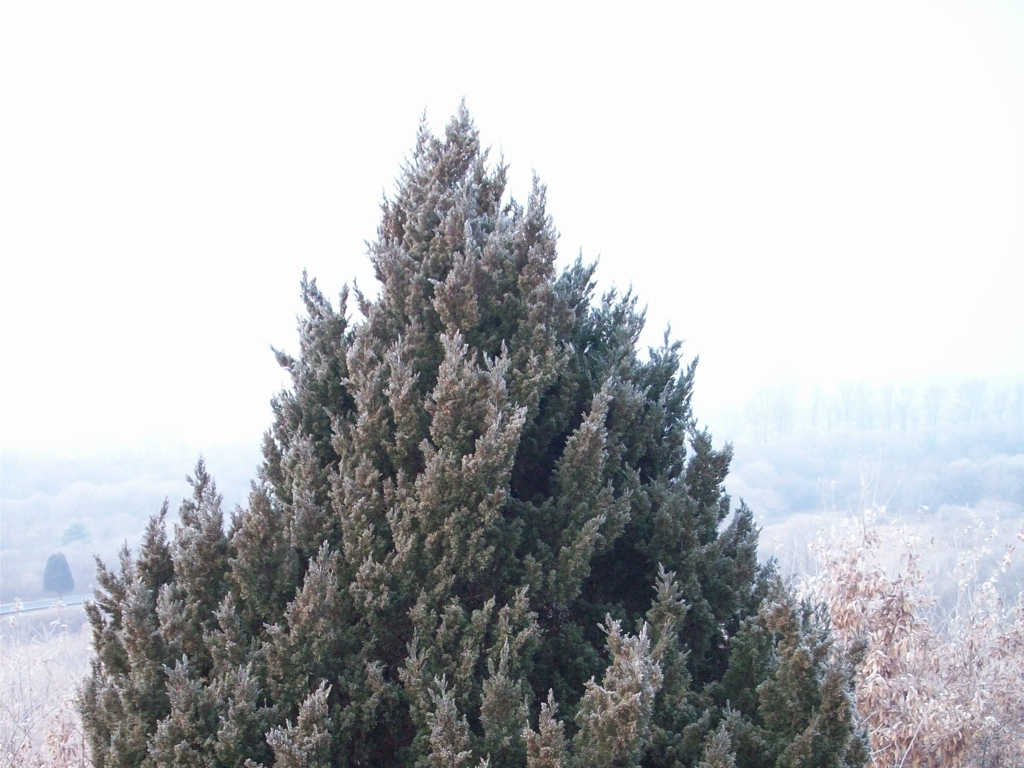What can be observed in this image?
A. lush green leaves
B. brown soil
C. thick fog The image prominently features a coniferous tree covered in frost, with its needles displaying a hue that ranges from a darker green at the lower branches to a lighter, frost-touched color as you look upwards. There is a visible haziness in the background, which might suggest the presence of fog, indicating that the correct answer includes both A and C. It appears to be a cold, possibly winter morning, with the tree standing as a thick and towering presence in the environment. 